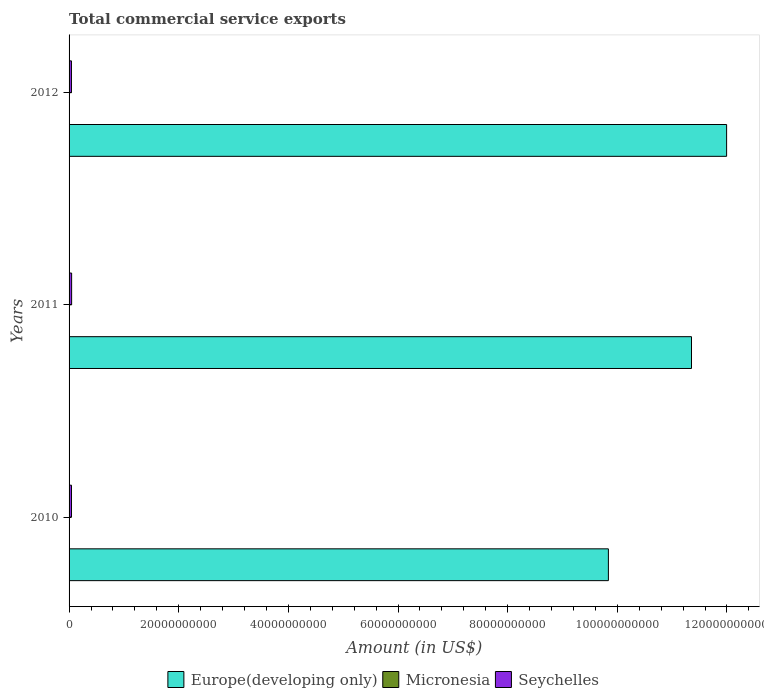Are the number of bars per tick equal to the number of legend labels?
Your answer should be compact. Yes. Are the number of bars on each tick of the Y-axis equal?
Provide a succinct answer. Yes. How many bars are there on the 1st tick from the top?
Give a very brief answer. 3. What is the total commercial service exports in Seychelles in 2012?
Ensure brevity in your answer.  4.33e+08. Across all years, what is the maximum total commercial service exports in Micronesia?
Make the answer very short. 3.50e+07. Across all years, what is the minimum total commercial service exports in Micronesia?
Provide a succinct answer. 3.13e+07. In which year was the total commercial service exports in Micronesia maximum?
Your answer should be very brief. 2010. What is the total total commercial service exports in Micronesia in the graph?
Give a very brief answer. 1.00e+08. What is the difference between the total commercial service exports in Europe(developing only) in 2010 and that in 2011?
Make the answer very short. -1.52e+1. What is the difference between the total commercial service exports in Europe(developing only) in 2010 and the total commercial service exports in Seychelles in 2011?
Give a very brief answer. 9.79e+1. What is the average total commercial service exports in Seychelles per year?
Keep it short and to the point. 4.46e+08. In the year 2012, what is the difference between the total commercial service exports in Micronesia and total commercial service exports in Seychelles?
Provide a short and direct response. -3.99e+08. In how many years, is the total commercial service exports in Europe(developing only) greater than 24000000000 US$?
Offer a terse response. 3. What is the ratio of the total commercial service exports in Europe(developing only) in 2010 to that in 2011?
Your answer should be compact. 0.87. Is the total commercial service exports in Europe(developing only) in 2010 less than that in 2011?
Offer a terse response. Yes. What is the difference between the highest and the second highest total commercial service exports in Seychelles?
Your response must be concise. 2.50e+07. What is the difference between the highest and the lowest total commercial service exports in Seychelles?
Provide a short and direct response. 3.23e+07. In how many years, is the total commercial service exports in Micronesia greater than the average total commercial service exports in Micronesia taken over all years?
Make the answer very short. 2. Is the sum of the total commercial service exports in Seychelles in 2010 and 2011 greater than the maximum total commercial service exports in Europe(developing only) across all years?
Provide a short and direct response. No. What does the 3rd bar from the top in 2012 represents?
Offer a very short reply. Europe(developing only). What does the 3rd bar from the bottom in 2010 represents?
Your answer should be very brief. Seychelles. Is it the case that in every year, the sum of the total commercial service exports in Seychelles and total commercial service exports in Europe(developing only) is greater than the total commercial service exports in Micronesia?
Make the answer very short. Yes. How many bars are there?
Make the answer very short. 9. Are all the bars in the graph horizontal?
Your response must be concise. Yes. What is the difference between two consecutive major ticks on the X-axis?
Ensure brevity in your answer.  2.00e+1. Are the values on the major ticks of X-axis written in scientific E-notation?
Your response must be concise. No. Where does the legend appear in the graph?
Offer a terse response. Bottom center. How are the legend labels stacked?
Give a very brief answer. Horizontal. What is the title of the graph?
Your answer should be very brief. Total commercial service exports. Does "Singapore" appear as one of the legend labels in the graph?
Ensure brevity in your answer.  No. What is the label or title of the Y-axis?
Keep it short and to the point. Years. What is the Amount (in US$) of Europe(developing only) in 2010?
Provide a short and direct response. 9.84e+1. What is the Amount (in US$) of Micronesia in 2010?
Give a very brief answer. 3.50e+07. What is the Amount (in US$) of Seychelles in 2010?
Keep it short and to the point. 4.40e+08. What is the Amount (in US$) in Europe(developing only) in 2011?
Ensure brevity in your answer.  1.14e+11. What is the Amount (in US$) of Micronesia in 2011?
Your answer should be very brief. 3.13e+07. What is the Amount (in US$) in Seychelles in 2011?
Provide a short and direct response. 4.65e+08. What is the Amount (in US$) in Europe(developing only) in 2012?
Provide a succinct answer. 1.20e+11. What is the Amount (in US$) of Micronesia in 2012?
Ensure brevity in your answer.  3.40e+07. What is the Amount (in US$) of Seychelles in 2012?
Give a very brief answer. 4.33e+08. Across all years, what is the maximum Amount (in US$) in Europe(developing only)?
Make the answer very short. 1.20e+11. Across all years, what is the maximum Amount (in US$) of Micronesia?
Keep it short and to the point. 3.50e+07. Across all years, what is the maximum Amount (in US$) of Seychelles?
Your answer should be very brief. 4.65e+08. Across all years, what is the minimum Amount (in US$) of Europe(developing only)?
Ensure brevity in your answer.  9.84e+1. Across all years, what is the minimum Amount (in US$) of Micronesia?
Ensure brevity in your answer.  3.13e+07. Across all years, what is the minimum Amount (in US$) in Seychelles?
Offer a terse response. 4.33e+08. What is the total Amount (in US$) of Europe(developing only) in the graph?
Offer a terse response. 3.32e+11. What is the total Amount (in US$) of Micronesia in the graph?
Give a very brief answer. 1.00e+08. What is the total Amount (in US$) in Seychelles in the graph?
Keep it short and to the point. 1.34e+09. What is the difference between the Amount (in US$) in Europe(developing only) in 2010 and that in 2011?
Provide a short and direct response. -1.52e+1. What is the difference between the Amount (in US$) in Micronesia in 2010 and that in 2011?
Ensure brevity in your answer.  3.70e+06. What is the difference between the Amount (in US$) of Seychelles in 2010 and that in 2011?
Your response must be concise. -2.50e+07. What is the difference between the Amount (in US$) of Europe(developing only) in 2010 and that in 2012?
Provide a succinct answer. -2.16e+1. What is the difference between the Amount (in US$) of Micronesia in 2010 and that in 2012?
Offer a very short reply. 9.99e+05. What is the difference between the Amount (in US$) in Seychelles in 2010 and that in 2012?
Offer a terse response. 7.30e+06. What is the difference between the Amount (in US$) of Europe(developing only) in 2011 and that in 2012?
Your answer should be compact. -6.41e+09. What is the difference between the Amount (in US$) of Micronesia in 2011 and that in 2012?
Give a very brief answer. -2.70e+06. What is the difference between the Amount (in US$) of Seychelles in 2011 and that in 2012?
Your response must be concise. 3.23e+07. What is the difference between the Amount (in US$) of Europe(developing only) in 2010 and the Amount (in US$) of Micronesia in 2011?
Your answer should be very brief. 9.83e+1. What is the difference between the Amount (in US$) of Europe(developing only) in 2010 and the Amount (in US$) of Seychelles in 2011?
Your answer should be compact. 9.79e+1. What is the difference between the Amount (in US$) in Micronesia in 2010 and the Amount (in US$) in Seychelles in 2011?
Give a very brief answer. -4.31e+08. What is the difference between the Amount (in US$) of Europe(developing only) in 2010 and the Amount (in US$) of Micronesia in 2012?
Your response must be concise. 9.83e+1. What is the difference between the Amount (in US$) in Europe(developing only) in 2010 and the Amount (in US$) in Seychelles in 2012?
Offer a very short reply. 9.79e+1. What is the difference between the Amount (in US$) in Micronesia in 2010 and the Amount (in US$) in Seychelles in 2012?
Provide a succinct answer. -3.98e+08. What is the difference between the Amount (in US$) of Europe(developing only) in 2011 and the Amount (in US$) of Micronesia in 2012?
Your answer should be very brief. 1.14e+11. What is the difference between the Amount (in US$) of Europe(developing only) in 2011 and the Amount (in US$) of Seychelles in 2012?
Keep it short and to the point. 1.13e+11. What is the difference between the Amount (in US$) of Micronesia in 2011 and the Amount (in US$) of Seychelles in 2012?
Keep it short and to the point. -4.02e+08. What is the average Amount (in US$) of Europe(developing only) per year?
Provide a short and direct response. 1.11e+11. What is the average Amount (in US$) of Micronesia per year?
Provide a succinct answer. 3.34e+07. What is the average Amount (in US$) of Seychelles per year?
Ensure brevity in your answer.  4.46e+08. In the year 2010, what is the difference between the Amount (in US$) of Europe(developing only) and Amount (in US$) of Micronesia?
Your answer should be compact. 9.83e+1. In the year 2010, what is the difference between the Amount (in US$) of Europe(developing only) and Amount (in US$) of Seychelles?
Give a very brief answer. 9.79e+1. In the year 2010, what is the difference between the Amount (in US$) of Micronesia and Amount (in US$) of Seychelles?
Your answer should be compact. -4.05e+08. In the year 2011, what is the difference between the Amount (in US$) in Europe(developing only) and Amount (in US$) in Micronesia?
Your response must be concise. 1.14e+11. In the year 2011, what is the difference between the Amount (in US$) of Europe(developing only) and Amount (in US$) of Seychelles?
Provide a short and direct response. 1.13e+11. In the year 2011, what is the difference between the Amount (in US$) in Micronesia and Amount (in US$) in Seychelles?
Your answer should be very brief. -4.34e+08. In the year 2012, what is the difference between the Amount (in US$) of Europe(developing only) and Amount (in US$) of Micronesia?
Make the answer very short. 1.20e+11. In the year 2012, what is the difference between the Amount (in US$) of Europe(developing only) and Amount (in US$) of Seychelles?
Provide a succinct answer. 1.20e+11. In the year 2012, what is the difference between the Amount (in US$) in Micronesia and Amount (in US$) in Seychelles?
Your answer should be very brief. -3.99e+08. What is the ratio of the Amount (in US$) of Europe(developing only) in 2010 to that in 2011?
Provide a succinct answer. 0.87. What is the ratio of the Amount (in US$) of Micronesia in 2010 to that in 2011?
Make the answer very short. 1.12. What is the ratio of the Amount (in US$) of Seychelles in 2010 to that in 2011?
Provide a short and direct response. 0.95. What is the ratio of the Amount (in US$) of Europe(developing only) in 2010 to that in 2012?
Your response must be concise. 0.82. What is the ratio of the Amount (in US$) of Micronesia in 2010 to that in 2012?
Your response must be concise. 1.03. What is the ratio of the Amount (in US$) in Seychelles in 2010 to that in 2012?
Your response must be concise. 1.02. What is the ratio of the Amount (in US$) in Europe(developing only) in 2011 to that in 2012?
Make the answer very short. 0.95. What is the ratio of the Amount (in US$) in Micronesia in 2011 to that in 2012?
Give a very brief answer. 0.92. What is the ratio of the Amount (in US$) in Seychelles in 2011 to that in 2012?
Give a very brief answer. 1.07. What is the difference between the highest and the second highest Amount (in US$) in Europe(developing only)?
Provide a short and direct response. 6.41e+09. What is the difference between the highest and the second highest Amount (in US$) of Micronesia?
Your answer should be compact. 9.99e+05. What is the difference between the highest and the second highest Amount (in US$) in Seychelles?
Give a very brief answer. 2.50e+07. What is the difference between the highest and the lowest Amount (in US$) of Europe(developing only)?
Your answer should be very brief. 2.16e+1. What is the difference between the highest and the lowest Amount (in US$) of Micronesia?
Offer a very short reply. 3.70e+06. What is the difference between the highest and the lowest Amount (in US$) in Seychelles?
Provide a succinct answer. 3.23e+07. 